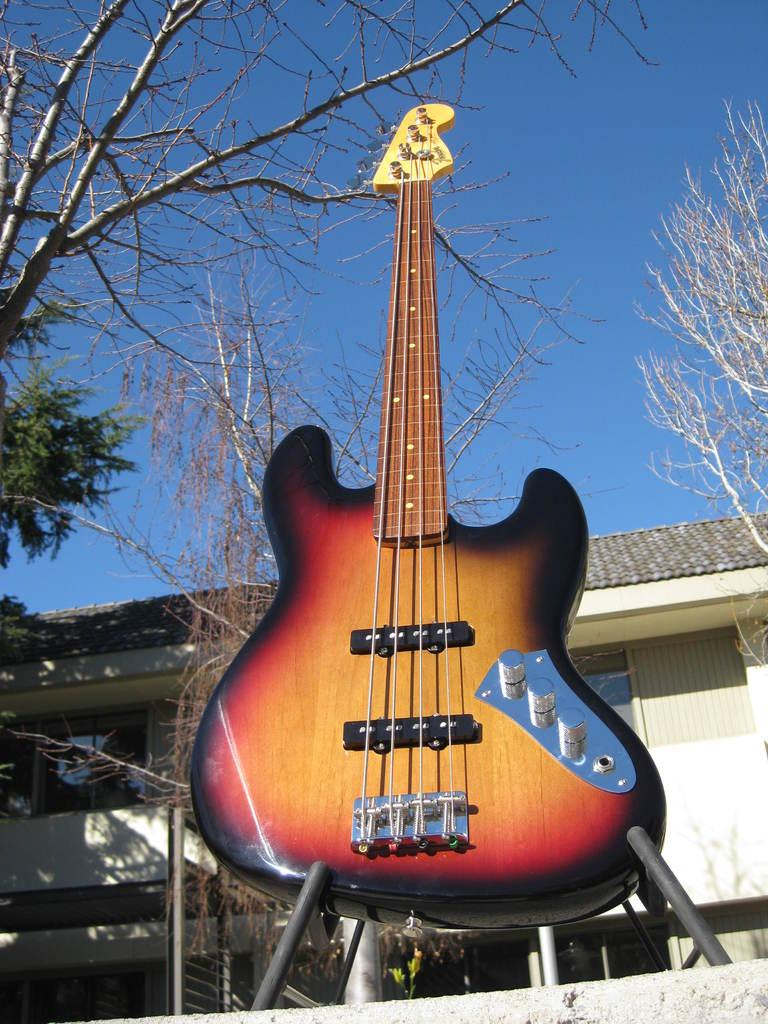What is the main object in the center of the image? There is a guitar in the center of the image. What can be seen in the background of the image? There is a clear sky, trees, and a building in the background of the image. What type of feather is used to play the guitar in the image? There is no feather present in the image, and feathers are not used to play guitars. 